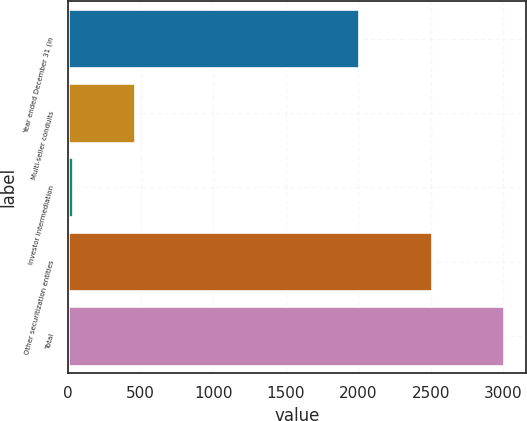<chart> <loc_0><loc_0><loc_500><loc_500><bar_chart><fcel>Year ended December 31 (in<fcel>Multi-seller conduits<fcel>Investor intermediation<fcel>Other securitization entities<fcel>Total<nl><fcel>2009<fcel>460<fcel>34<fcel>2510<fcel>3004<nl></chart> 